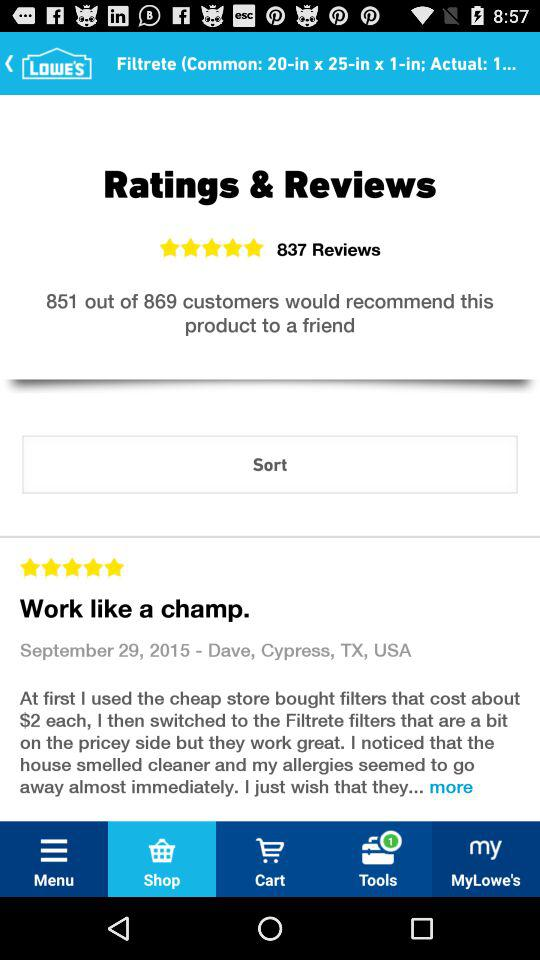What are the total number of reviews shown on the screen? The total number of reviews shown on the screen is 837. 